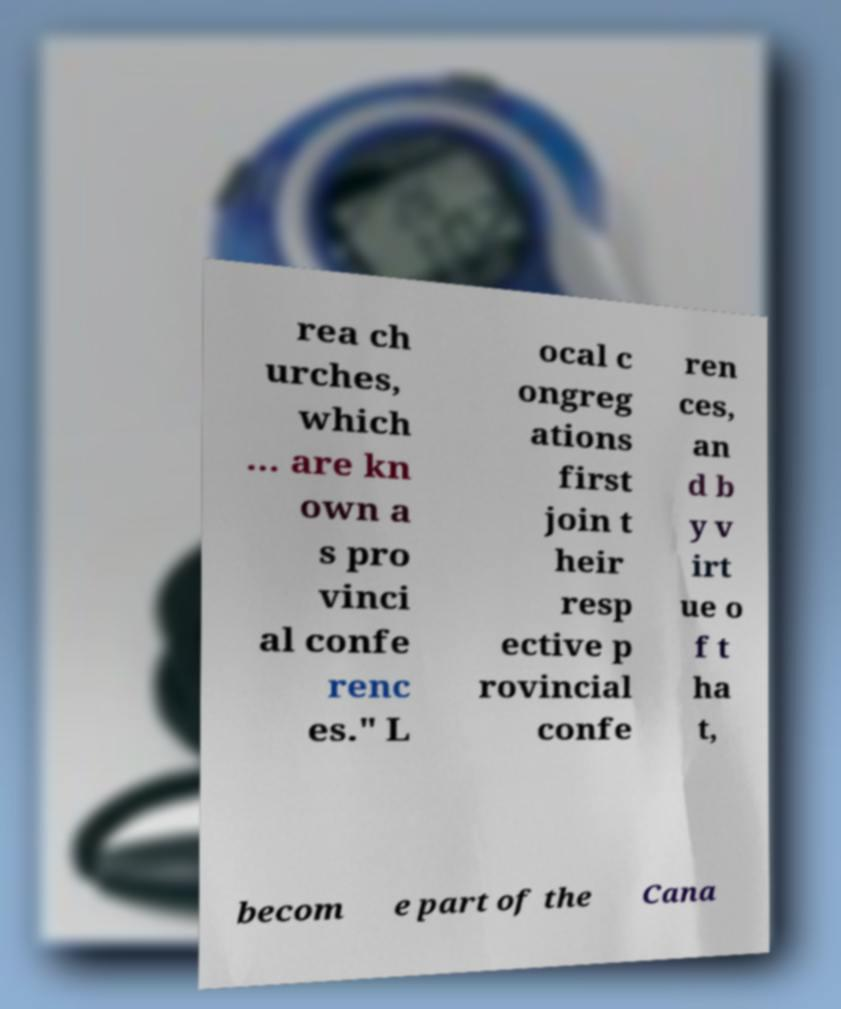Please identify and transcribe the text found in this image. rea ch urches, which ... are kn own a s pro vinci al confe renc es." L ocal c ongreg ations first join t heir resp ective p rovincial confe ren ces, an d b y v irt ue o f t ha t, becom e part of the Cana 